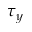Convert formula to latex. <formula><loc_0><loc_0><loc_500><loc_500>\tau _ { y }</formula> 